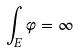<formula> <loc_0><loc_0><loc_500><loc_500>\int _ { E } \varphi = \infty</formula> 